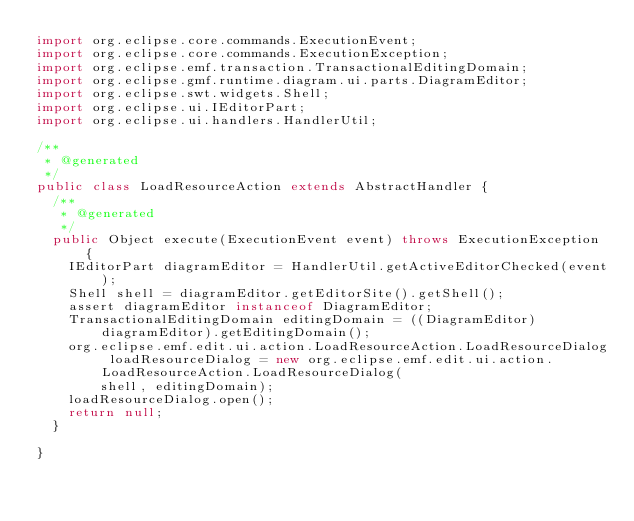Convert code to text. <code><loc_0><loc_0><loc_500><loc_500><_Java_>import org.eclipse.core.commands.ExecutionEvent;
import org.eclipse.core.commands.ExecutionException;
import org.eclipse.emf.transaction.TransactionalEditingDomain;
import org.eclipse.gmf.runtime.diagram.ui.parts.DiagramEditor;
import org.eclipse.swt.widgets.Shell;
import org.eclipse.ui.IEditorPart;
import org.eclipse.ui.handlers.HandlerUtil;

/**
 * @generated
 */
public class LoadResourceAction extends AbstractHandler {
  /**
   * @generated
   */
  public Object execute(ExecutionEvent event) throws ExecutionException {
    IEditorPart diagramEditor = HandlerUtil.getActiveEditorChecked(event);
    Shell shell = diagramEditor.getEditorSite().getShell();
    assert diagramEditor instanceof DiagramEditor;
    TransactionalEditingDomain editingDomain = ((DiagramEditor) diagramEditor).getEditingDomain();
    org.eclipse.emf.edit.ui.action.LoadResourceAction.LoadResourceDialog loadResourceDialog = new org.eclipse.emf.edit.ui.action.LoadResourceAction.LoadResourceDialog(
        shell, editingDomain);
    loadResourceDialog.open();
    return null;
  }

}
</code> 